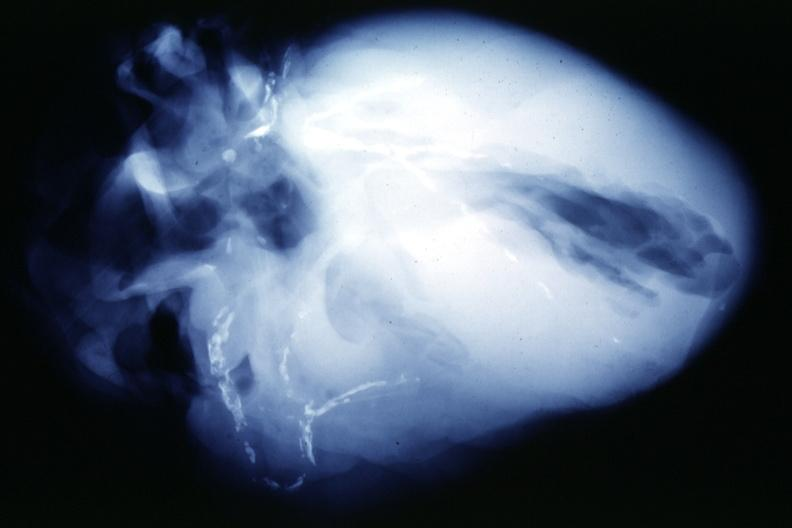s coronary artery present?
Answer the question using a single word or phrase. Yes 